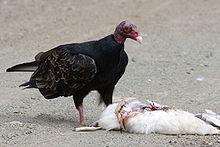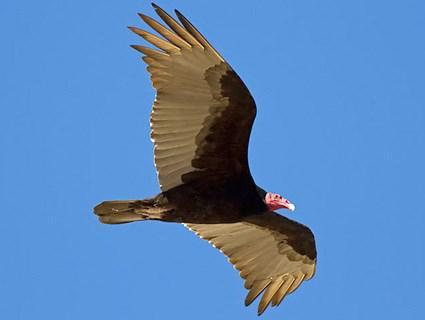The first image is the image on the left, the second image is the image on the right. For the images shown, is this caption "The vulture on the right image is flying facing right." true? Answer yes or no. Yes. The first image is the image on the left, the second image is the image on the right. For the images shown, is this caption "A total of three vultures are shown." true? Answer yes or no. No. 